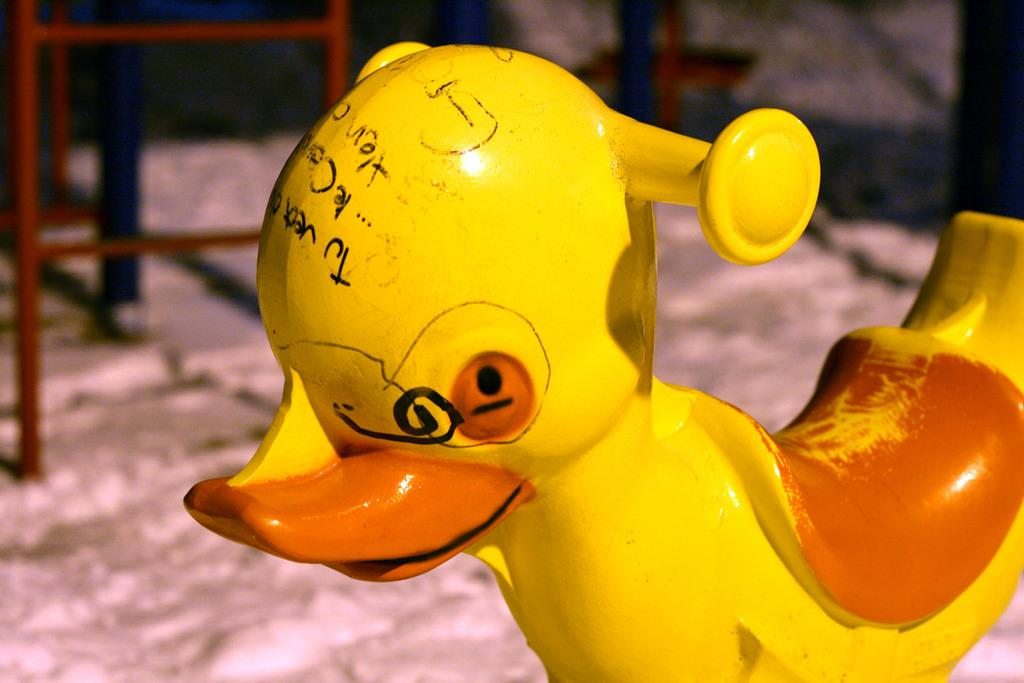What is the main subject in the center of the image? There is a toy in the center of the image. Where is the toy located? The toy is on the ground. What can be seen in the background of the image? There is a chair and a wall in the background of the image. What type of business is being conducted in the image? There is no indication of any business being conducted in the image; it primarily features a toy on the ground. 